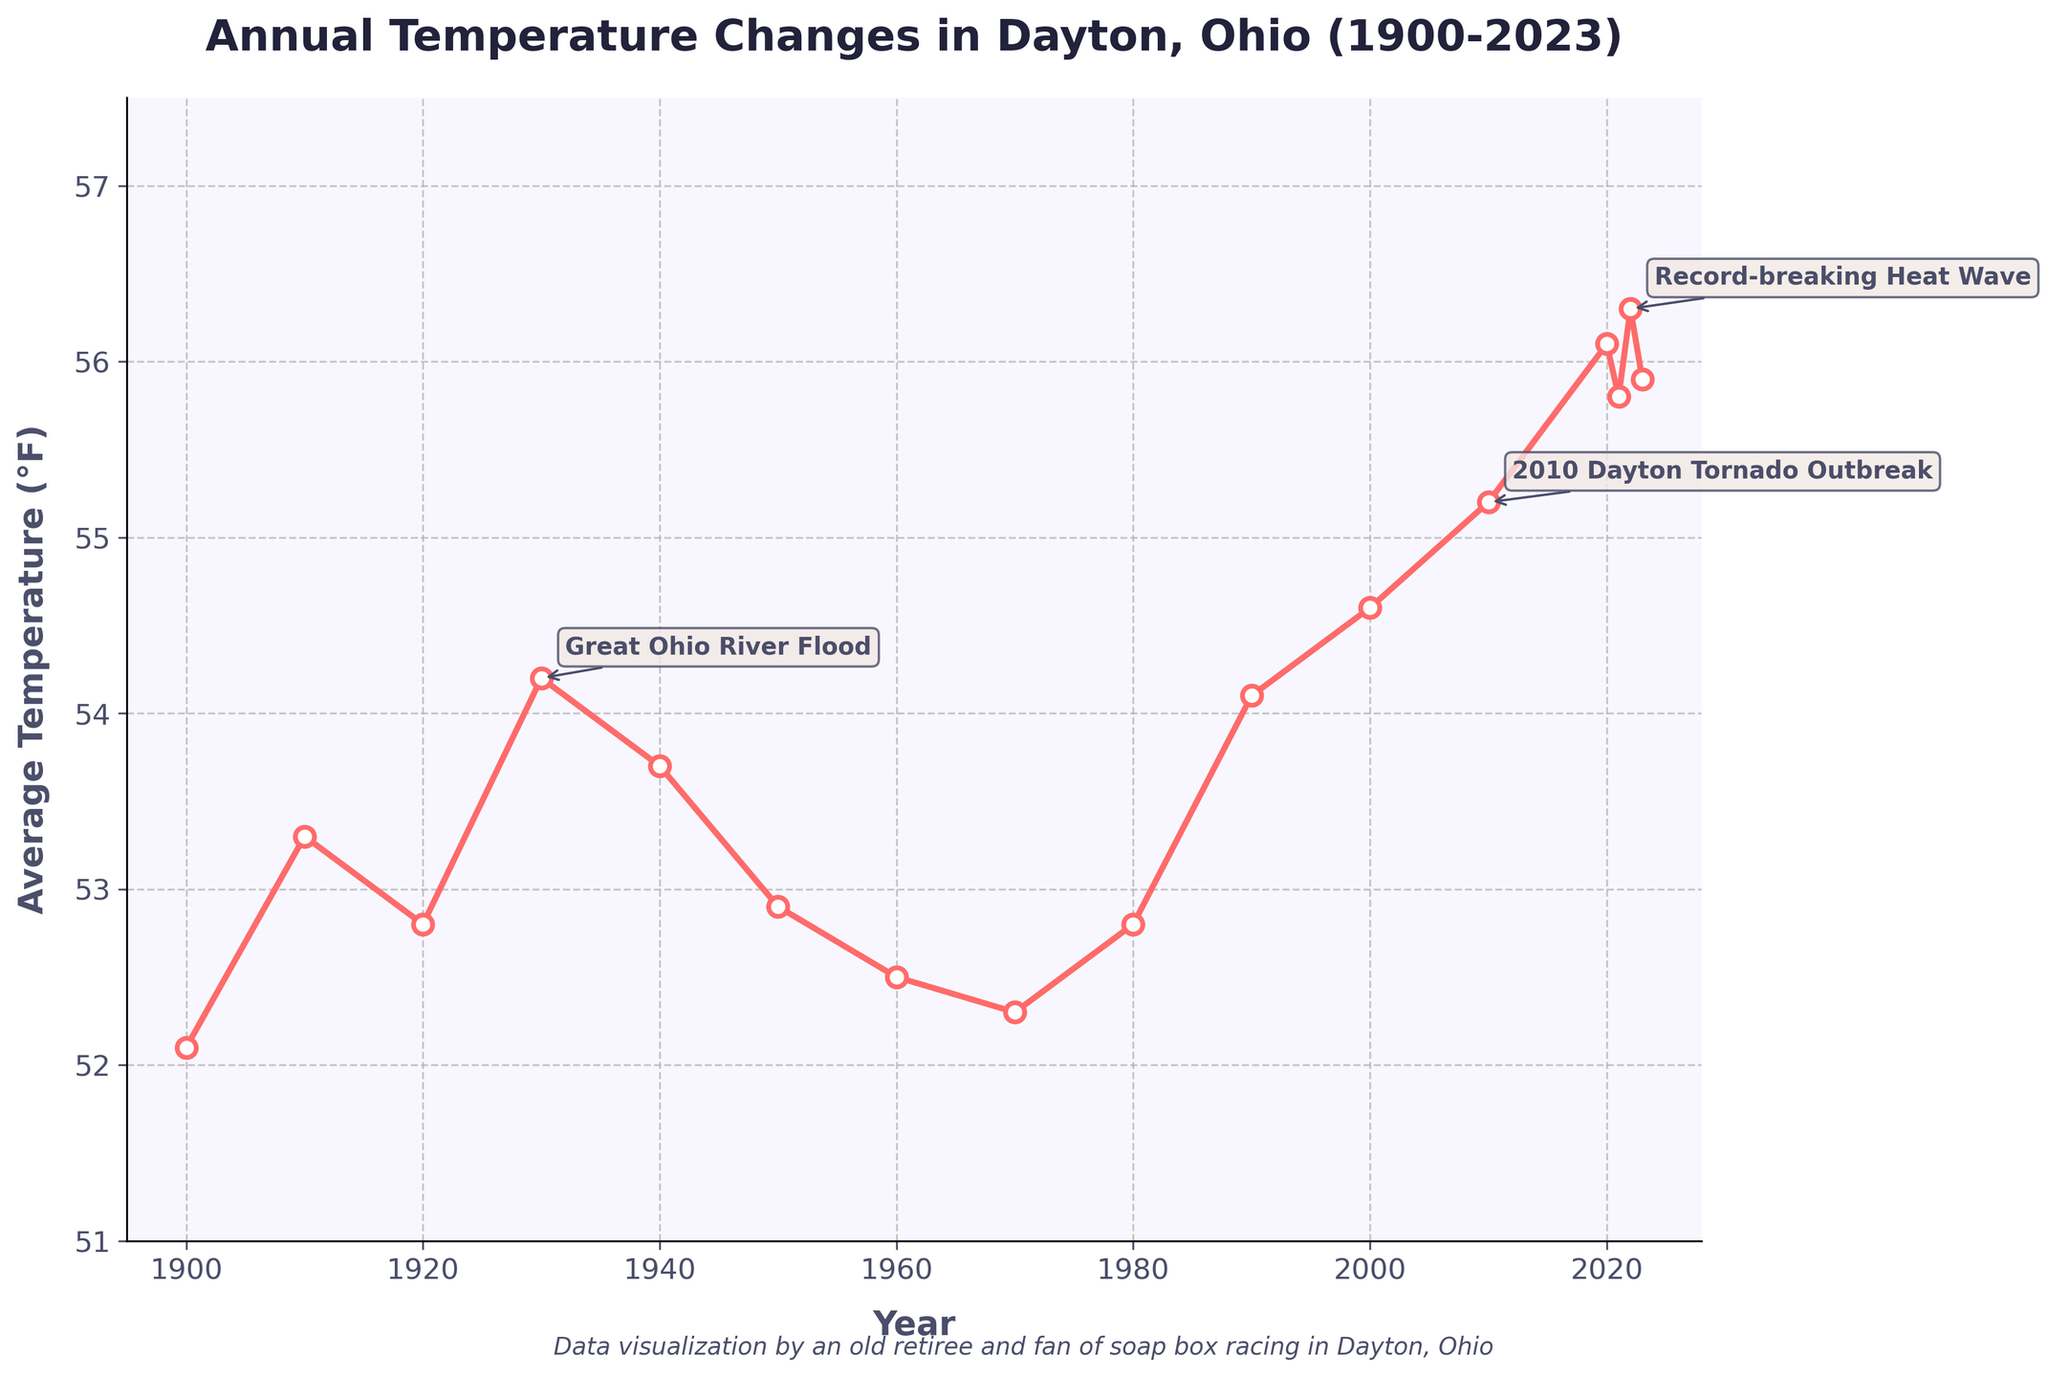what's the average annual temperature in Dayton for the years 2000, 2010, and 2020 combined? To find the average annual temperature for these years, first sum up the temperatures for 2000, 2010, and 2020, then divide by the number of years. The temperatures are 54.6, 55.2, and 56.1, respectively. Sum them up: 54.6 + 55.2 + 56.1 = 165.9. Divide by 3: 165.9 / 3 = 55.3.
Answer: 55.3°F which year showed the highest average temperature in Dayton? Examine the plot to find the year with the highest data point on the temperature line. The highest point appears around 2022, which has an average temperature of 56.3°F.
Answer: 2022 how much did the average annual temperature increase in Dayton from 1900 to 2022? Find the average temperatures for 1900 and 2022. Subtract the temperature in 1900 from the temperature in 2022 to get the increase. The temperatures are 52.1°F and 56.3°F, respectively. So, 56.3 - 52.1 = 4.2.
Answer: 4.2°F compare the average temperatures between the years 1930 (Great Ohio River Flood) and 2010 (Dayton Tornado Outbreak). which event year was warmer? Locate the points for 1930 and 2010 in the plot. The average temperature for 1930 is 54.2°F, and for 2010 it is 55.2°F. Since 55.2°F is greater than 54.2°F, the 2010 event year was warmer.
Answer: 2010 during which event did Dayton experience a temperature above 55°F that is also marked as an extreme weather event? Identify the extreme weather events marked on the plot and check their temperatures. Both 2010 (Dayton Tornado Outbreak with 55.2°F) and 2022 (Record-breaking Heat Wave with 56.3°F) were above 55°F.
Answer: 2010 and 2022 what is the range of the average temperatures from 1900 to 2023? To find the range, identify the highest and lowest average temperatures in the dataset. The lowest is in 1900 at 52.1°F, and the highest is in 2022 at 56.3°F. The range is 56.3 - 52.1 = 4.2.
Answer: 4.2°F how does the average temperature in 2021 compare to that in 2020? Locate the points for 2020 and 2021. The temperature in 2020 is 56.1°F, and in 2021 it is 55.8°F. Since 56.1 is greater than 55.8, the temperature decreased from 2020 to 2021.
Answer: decreased 